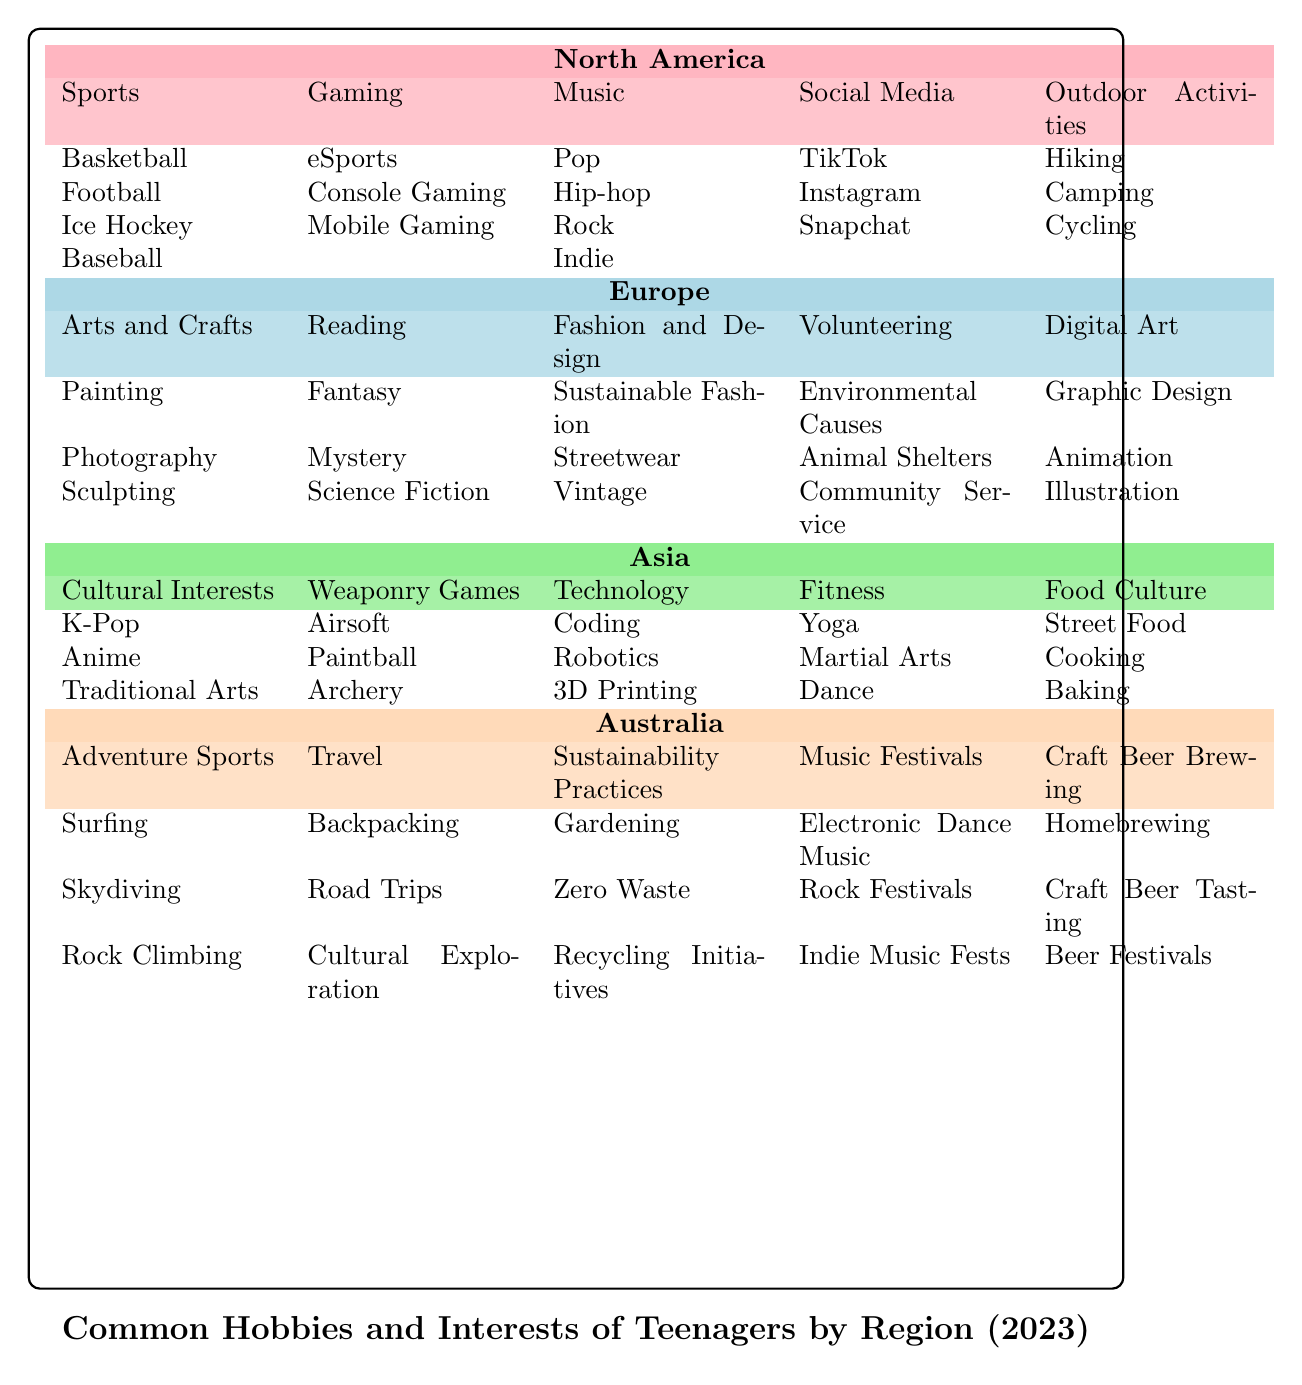What are the subcategories of Sports in North America? The table shows that under the Sports category in North America, the subcategories listed are Basketball, Football, Ice Hockey, and Baseball.
Answer: Basketball, Football, Ice Hockey, Baseball Is Digital Art a hobby in Europe? Yes, Digital Art is indeed listed as a hobby in Europe. It includes subcategories such as Graphic Design, Animation, and Illustration.
Answer: Yes How many different hobbies are listed for Asia? In the table, Asia has 5 distinct hobbies: Cultural Interests, Weaponry Games, Technology, Fitness, and Food Culture. Hence, there are a total of 5 hobbies.
Answer: 5 What is the average number of subcategories for hobbies across all regions? To find the average, we count the number of subcategories for each hobby: North America (5), Europe (5), Asia (5), Australia (5). Each region has 5 hobbies with 3 to 4 subcategories on average. Therefore, the average is also 5, since each hobby has 3 or more subcategories.
Answer: 5 Are there any hobbies specific to just Australia? Yes, Adventure Sports, Travel, Sustainability Practices, Music Festivals, and Craft Beer Brewing are specific to Australia, meaning they do not appear in other regions.
Answer: Yes Which region has a focus on Fitness-related activities? Asia has a focus on Fitness-related activities, with subcategories that include Yoga, Martial Arts, and Dance under the Fitness hobby.
Answer: Asia What is the total number of subcategories listed under Arts and Crafts in Europe? Under Arts and Crafts in Europe, there are 3 subcategories: Painting, Photography, and Sculpting. Therefore, the total number of subcategories is 3.
Answer: 3 Is K-Pop included as a hobby in North America? No, K-Pop is listed under Cultural Interests, which is categorized as a hobby in Asia.
Answer: No How does the focus on Outdoor Activities in North America compare to Adventure Sports in Australia? North America has Outdoor Activities with subcategories like Hiking, Camping, and Cycling, while Australia’s Adventure Sports includes Surfing, Skydiving, and Rock Climbing. Both regions emphasize outdoor-related hobbies, but they differ in specifics.
Answer: Similar focus on outdoor activities but different specifics 